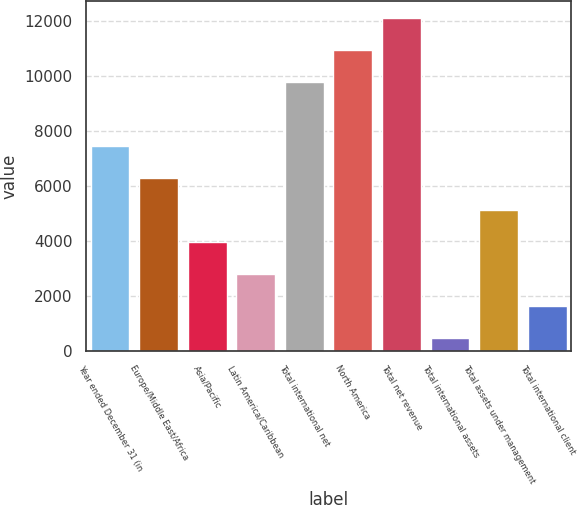<chart> <loc_0><loc_0><loc_500><loc_500><bar_chart><fcel>Year ended December 31 (in<fcel>Europe/Middle East/Africa<fcel>Asia/Pacific<fcel>Latin America/Caribbean<fcel>Total international net<fcel>North America<fcel>Total net revenue<fcel>Total international assets<fcel>Total assets under management<fcel>Total international client<nl><fcel>7459.4<fcel>6294.5<fcel>3964.7<fcel>2799.8<fcel>9789.2<fcel>10954.1<fcel>12119<fcel>470<fcel>5129.6<fcel>1634.9<nl></chart> 